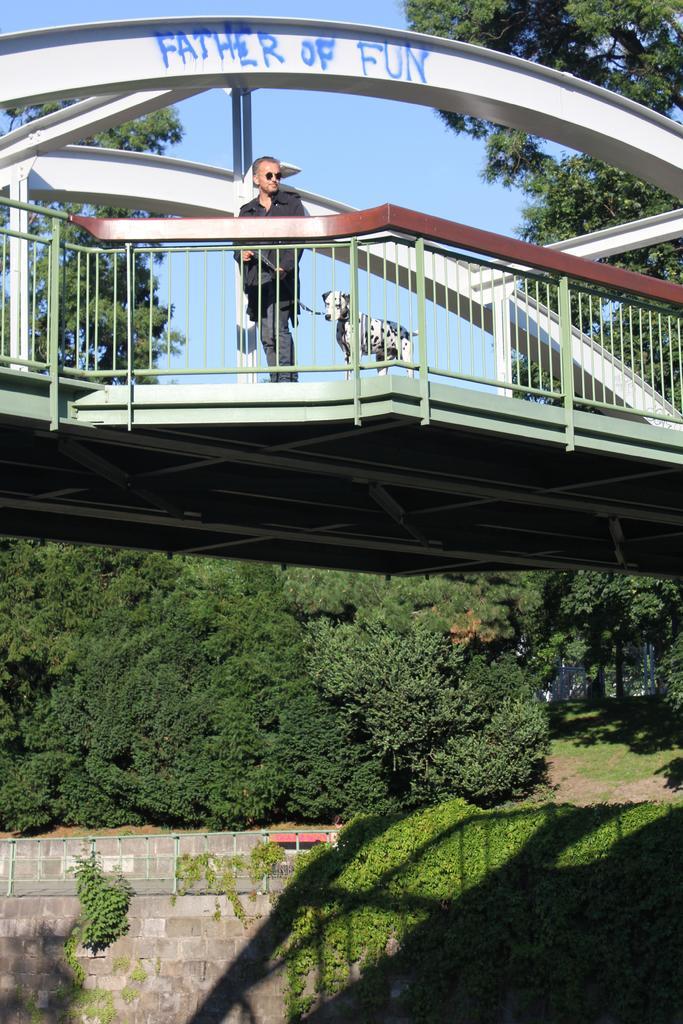How would you summarize this image in a sentence or two? There is a man standing on a bridge, beside him we can see a dog and we can see fence. In the background we can see grass, wall, trees and sky. 